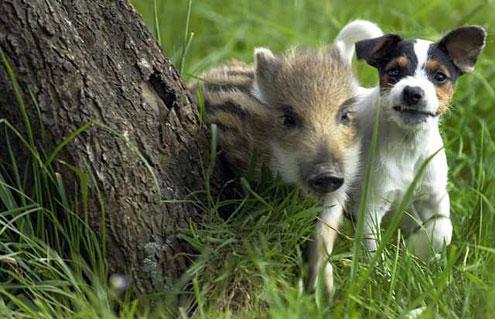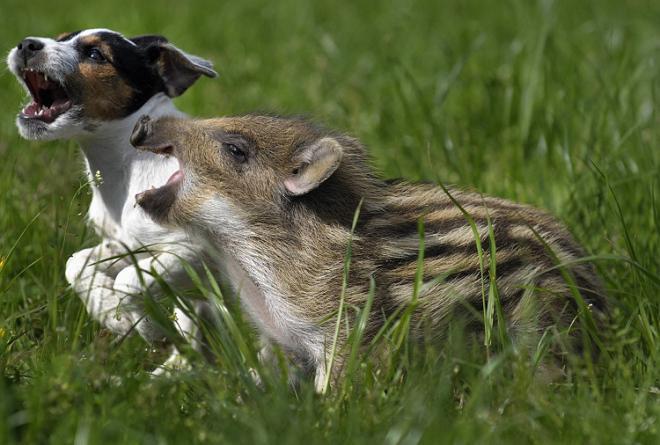The first image is the image on the left, the second image is the image on the right. Considering the images on both sides, is "One pig is moving across the pavement." valid? Answer yes or no. No. The first image is the image on the left, the second image is the image on the right. Assess this claim about the two images: "An image shows a striped baby wild pig standing parallel to a dog with its mouth open wide.". Correct or not? Answer yes or no. Yes. 